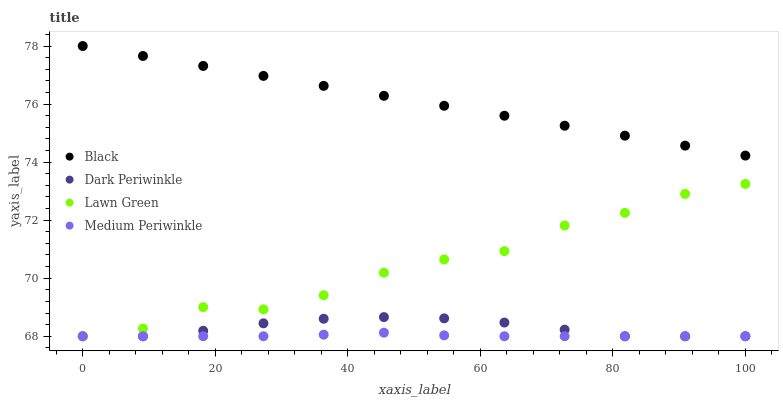Does Medium Periwinkle have the minimum area under the curve?
Answer yes or no. Yes. Does Black have the maximum area under the curve?
Answer yes or no. Yes. Does Dark Periwinkle have the minimum area under the curve?
Answer yes or no. No. Does Dark Periwinkle have the maximum area under the curve?
Answer yes or no. No. Is Black the smoothest?
Answer yes or no. Yes. Is Lawn Green the roughest?
Answer yes or no. Yes. Is Dark Periwinkle the smoothest?
Answer yes or no. No. Is Dark Periwinkle the roughest?
Answer yes or no. No. Does Lawn Green have the lowest value?
Answer yes or no. Yes. Does Black have the lowest value?
Answer yes or no. No. Does Black have the highest value?
Answer yes or no. Yes. Does Dark Periwinkle have the highest value?
Answer yes or no. No. Is Medium Periwinkle less than Black?
Answer yes or no. Yes. Is Black greater than Dark Periwinkle?
Answer yes or no. Yes. Does Lawn Green intersect Medium Periwinkle?
Answer yes or no. Yes. Is Lawn Green less than Medium Periwinkle?
Answer yes or no. No. Is Lawn Green greater than Medium Periwinkle?
Answer yes or no. No. Does Medium Periwinkle intersect Black?
Answer yes or no. No. 